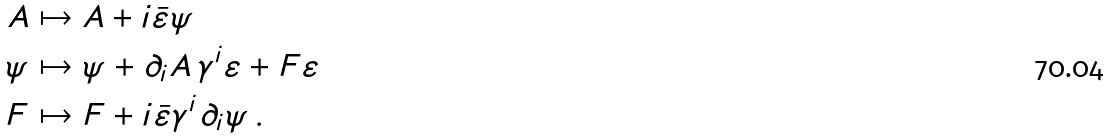Convert formula to latex. <formula><loc_0><loc_0><loc_500><loc_500>A & \mapsto A + i \bar { \varepsilon } \psi \\ \psi & \mapsto \psi + \partial _ { i } A \, \gamma ^ { i } \varepsilon + F \varepsilon \\ F & \mapsto F + i \bar { \varepsilon } \gamma ^ { i } \partial _ { i } \psi \, .</formula> 